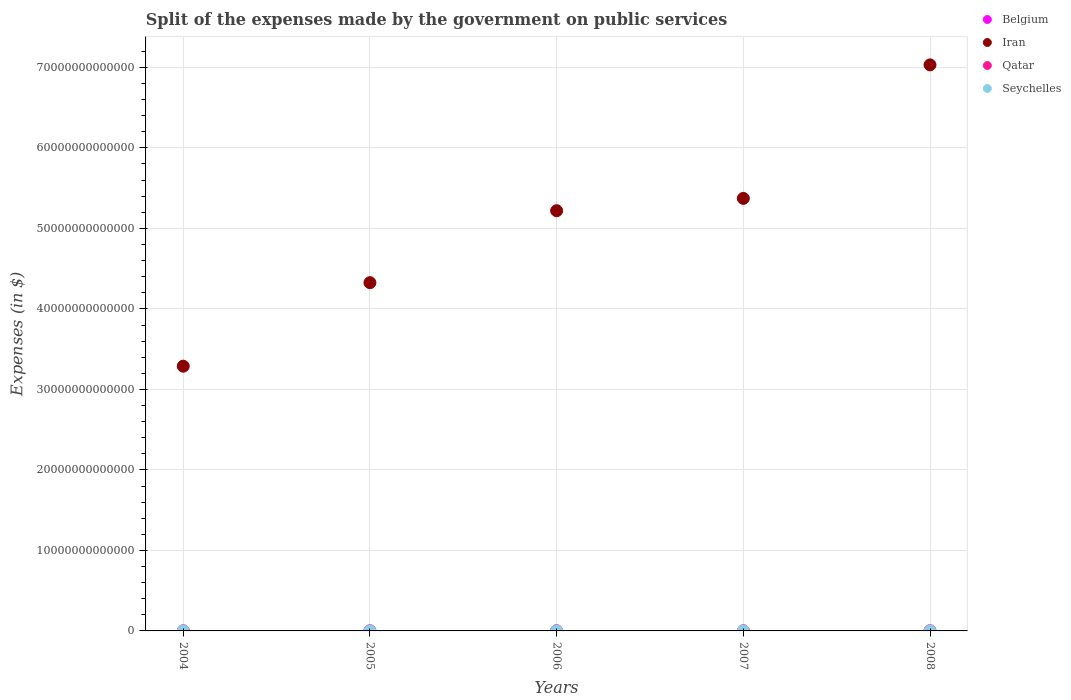What is the expenses made by the government on public services in Iran in 2008?
Offer a very short reply. 7.03e+13. Across all years, what is the maximum expenses made by the government on public services in Seychelles?
Your response must be concise. 6.48e+08. Across all years, what is the minimum expenses made by the government on public services in Iran?
Your response must be concise. 3.29e+13. In which year was the expenses made by the government on public services in Seychelles maximum?
Your answer should be compact. 2008. What is the total expenses made by the government on public services in Belgium in the graph?
Make the answer very short. 1.69e+1. What is the difference between the expenses made by the government on public services in Qatar in 2005 and that in 2006?
Your answer should be compact. -5.73e+09. What is the difference between the expenses made by the government on public services in Qatar in 2005 and the expenses made by the government on public services in Seychelles in 2008?
Your answer should be very brief. 1.16e+1. What is the average expenses made by the government on public services in Seychelles per year?
Offer a very short reply. 5.17e+08. In the year 2008, what is the difference between the expenses made by the government on public services in Seychelles and expenses made by the government on public services in Belgium?
Give a very brief answer. -3.30e+09. What is the ratio of the expenses made by the government on public services in Belgium in 2005 to that in 2007?
Provide a succinct answer. 0.93. Is the expenses made by the government on public services in Seychelles in 2006 less than that in 2008?
Ensure brevity in your answer.  Yes. Is the difference between the expenses made by the government on public services in Seychelles in 2004 and 2008 greater than the difference between the expenses made by the government on public services in Belgium in 2004 and 2008?
Keep it short and to the point. Yes. What is the difference between the highest and the second highest expenses made by the government on public services in Belgium?
Your response must be concise. 5.12e+08. What is the difference between the highest and the lowest expenses made by the government on public services in Seychelles?
Provide a short and direct response. 3.10e+08. Is the sum of the expenses made by the government on public services in Iran in 2005 and 2008 greater than the maximum expenses made by the government on public services in Qatar across all years?
Make the answer very short. Yes. Is it the case that in every year, the sum of the expenses made by the government on public services in Belgium and expenses made by the government on public services in Iran  is greater than the sum of expenses made by the government on public services in Qatar and expenses made by the government on public services in Seychelles?
Your answer should be compact. Yes. Does the expenses made by the government on public services in Iran monotonically increase over the years?
Provide a short and direct response. Yes. What is the difference between two consecutive major ticks on the Y-axis?
Your answer should be compact. 1.00e+13. Does the graph contain grids?
Ensure brevity in your answer.  Yes. How many legend labels are there?
Offer a very short reply. 4. What is the title of the graph?
Offer a very short reply. Split of the expenses made by the government on public services. Does "Central African Republic" appear as one of the legend labels in the graph?
Make the answer very short. No. What is the label or title of the Y-axis?
Your response must be concise. Expenses (in $). What is the Expenses (in $) in Belgium in 2004?
Your response must be concise. 3.14e+09. What is the Expenses (in $) in Iran in 2004?
Your answer should be very brief. 3.29e+13. What is the Expenses (in $) of Qatar in 2004?
Ensure brevity in your answer.  8.25e+09. What is the Expenses (in $) of Seychelles in 2004?
Your response must be concise. 3.38e+08. What is the Expenses (in $) of Belgium in 2005?
Ensure brevity in your answer.  3.21e+09. What is the Expenses (in $) of Iran in 2005?
Your answer should be compact. 4.33e+13. What is the Expenses (in $) in Qatar in 2005?
Give a very brief answer. 1.22e+1. What is the Expenses (in $) in Seychelles in 2005?
Ensure brevity in your answer.  4.63e+08. What is the Expenses (in $) in Belgium in 2006?
Offer a terse response. 3.16e+09. What is the Expenses (in $) of Iran in 2006?
Your response must be concise. 5.22e+13. What is the Expenses (in $) of Qatar in 2006?
Provide a short and direct response. 1.80e+1. What is the Expenses (in $) of Seychelles in 2006?
Provide a short and direct response. 5.24e+08. What is the Expenses (in $) of Belgium in 2007?
Make the answer very short. 3.44e+09. What is the Expenses (in $) of Iran in 2007?
Ensure brevity in your answer.  5.37e+13. What is the Expenses (in $) in Qatar in 2007?
Provide a short and direct response. 1.13e+1. What is the Expenses (in $) of Seychelles in 2007?
Provide a short and direct response. 6.12e+08. What is the Expenses (in $) of Belgium in 2008?
Your answer should be compact. 3.95e+09. What is the Expenses (in $) in Iran in 2008?
Make the answer very short. 7.03e+13. What is the Expenses (in $) in Qatar in 2008?
Your answer should be very brief. 1.74e+1. What is the Expenses (in $) of Seychelles in 2008?
Your answer should be very brief. 6.48e+08. Across all years, what is the maximum Expenses (in $) in Belgium?
Provide a short and direct response. 3.95e+09. Across all years, what is the maximum Expenses (in $) in Iran?
Your answer should be very brief. 7.03e+13. Across all years, what is the maximum Expenses (in $) in Qatar?
Your answer should be very brief. 1.80e+1. Across all years, what is the maximum Expenses (in $) of Seychelles?
Your answer should be compact. 6.48e+08. Across all years, what is the minimum Expenses (in $) of Belgium?
Keep it short and to the point. 3.14e+09. Across all years, what is the minimum Expenses (in $) of Iran?
Your answer should be compact. 3.29e+13. Across all years, what is the minimum Expenses (in $) in Qatar?
Make the answer very short. 8.25e+09. Across all years, what is the minimum Expenses (in $) in Seychelles?
Offer a terse response. 3.38e+08. What is the total Expenses (in $) in Belgium in the graph?
Make the answer very short. 1.69e+1. What is the total Expenses (in $) in Iran in the graph?
Your answer should be compact. 2.52e+14. What is the total Expenses (in $) in Qatar in the graph?
Offer a terse response. 6.72e+1. What is the total Expenses (in $) of Seychelles in the graph?
Your response must be concise. 2.59e+09. What is the difference between the Expenses (in $) of Belgium in 2004 and that in 2005?
Your response must be concise. -7.35e+07. What is the difference between the Expenses (in $) of Iran in 2004 and that in 2005?
Ensure brevity in your answer.  -1.04e+13. What is the difference between the Expenses (in $) in Qatar in 2004 and that in 2005?
Provide a succinct answer. -3.97e+09. What is the difference between the Expenses (in $) in Seychelles in 2004 and that in 2005?
Ensure brevity in your answer.  -1.25e+08. What is the difference between the Expenses (in $) in Belgium in 2004 and that in 2006?
Your answer should be compact. -1.81e+07. What is the difference between the Expenses (in $) in Iran in 2004 and that in 2006?
Make the answer very short. -1.93e+13. What is the difference between the Expenses (in $) in Qatar in 2004 and that in 2006?
Your answer should be compact. -9.70e+09. What is the difference between the Expenses (in $) of Seychelles in 2004 and that in 2006?
Offer a terse response. -1.86e+08. What is the difference between the Expenses (in $) in Belgium in 2004 and that in 2007?
Your answer should be compact. -2.98e+08. What is the difference between the Expenses (in $) of Iran in 2004 and that in 2007?
Provide a succinct answer. -2.08e+13. What is the difference between the Expenses (in $) in Qatar in 2004 and that in 2007?
Ensure brevity in your answer.  -3.06e+09. What is the difference between the Expenses (in $) of Seychelles in 2004 and that in 2007?
Your answer should be very brief. -2.74e+08. What is the difference between the Expenses (in $) in Belgium in 2004 and that in 2008?
Ensure brevity in your answer.  -8.09e+08. What is the difference between the Expenses (in $) in Iran in 2004 and that in 2008?
Provide a succinct answer. -3.74e+13. What is the difference between the Expenses (in $) in Qatar in 2004 and that in 2008?
Offer a terse response. -9.20e+09. What is the difference between the Expenses (in $) in Seychelles in 2004 and that in 2008?
Keep it short and to the point. -3.10e+08. What is the difference between the Expenses (in $) in Belgium in 2005 and that in 2006?
Your answer should be compact. 5.54e+07. What is the difference between the Expenses (in $) in Iran in 2005 and that in 2006?
Make the answer very short. -8.94e+12. What is the difference between the Expenses (in $) in Qatar in 2005 and that in 2006?
Ensure brevity in your answer.  -5.73e+09. What is the difference between the Expenses (in $) of Seychelles in 2005 and that in 2006?
Your answer should be compact. -6.15e+07. What is the difference between the Expenses (in $) in Belgium in 2005 and that in 2007?
Keep it short and to the point. -2.24e+08. What is the difference between the Expenses (in $) of Iran in 2005 and that in 2007?
Keep it short and to the point. -1.05e+13. What is the difference between the Expenses (in $) in Qatar in 2005 and that in 2007?
Ensure brevity in your answer.  9.13e+08. What is the difference between the Expenses (in $) in Seychelles in 2005 and that in 2007?
Offer a very short reply. -1.49e+08. What is the difference between the Expenses (in $) of Belgium in 2005 and that in 2008?
Make the answer very short. -7.36e+08. What is the difference between the Expenses (in $) of Iran in 2005 and that in 2008?
Provide a short and direct response. -2.71e+13. What is the difference between the Expenses (in $) of Qatar in 2005 and that in 2008?
Offer a terse response. -5.22e+09. What is the difference between the Expenses (in $) in Seychelles in 2005 and that in 2008?
Keep it short and to the point. -1.85e+08. What is the difference between the Expenses (in $) in Belgium in 2006 and that in 2007?
Provide a succinct answer. -2.80e+08. What is the difference between the Expenses (in $) in Iran in 2006 and that in 2007?
Your answer should be compact. -1.53e+12. What is the difference between the Expenses (in $) in Qatar in 2006 and that in 2007?
Give a very brief answer. 6.64e+09. What is the difference between the Expenses (in $) of Seychelles in 2006 and that in 2007?
Give a very brief answer. -8.75e+07. What is the difference between the Expenses (in $) in Belgium in 2006 and that in 2008?
Offer a very short reply. -7.91e+08. What is the difference between the Expenses (in $) of Iran in 2006 and that in 2008?
Keep it short and to the point. -1.81e+13. What is the difference between the Expenses (in $) of Qatar in 2006 and that in 2008?
Offer a terse response. 5.07e+08. What is the difference between the Expenses (in $) of Seychelles in 2006 and that in 2008?
Ensure brevity in your answer.  -1.24e+08. What is the difference between the Expenses (in $) of Belgium in 2007 and that in 2008?
Your response must be concise. -5.12e+08. What is the difference between the Expenses (in $) in Iran in 2007 and that in 2008?
Your response must be concise. -1.66e+13. What is the difference between the Expenses (in $) in Qatar in 2007 and that in 2008?
Offer a very short reply. -6.14e+09. What is the difference between the Expenses (in $) in Seychelles in 2007 and that in 2008?
Keep it short and to the point. -3.60e+07. What is the difference between the Expenses (in $) of Belgium in 2004 and the Expenses (in $) of Iran in 2005?
Make the answer very short. -4.33e+13. What is the difference between the Expenses (in $) of Belgium in 2004 and the Expenses (in $) of Qatar in 2005?
Make the answer very short. -9.08e+09. What is the difference between the Expenses (in $) in Belgium in 2004 and the Expenses (in $) in Seychelles in 2005?
Offer a very short reply. 2.68e+09. What is the difference between the Expenses (in $) of Iran in 2004 and the Expenses (in $) of Qatar in 2005?
Offer a very short reply. 3.29e+13. What is the difference between the Expenses (in $) in Iran in 2004 and the Expenses (in $) in Seychelles in 2005?
Your answer should be compact. 3.29e+13. What is the difference between the Expenses (in $) in Qatar in 2004 and the Expenses (in $) in Seychelles in 2005?
Provide a short and direct response. 7.79e+09. What is the difference between the Expenses (in $) in Belgium in 2004 and the Expenses (in $) in Iran in 2006?
Offer a terse response. -5.22e+13. What is the difference between the Expenses (in $) of Belgium in 2004 and the Expenses (in $) of Qatar in 2006?
Make the answer very short. -1.48e+1. What is the difference between the Expenses (in $) of Belgium in 2004 and the Expenses (in $) of Seychelles in 2006?
Provide a short and direct response. 2.62e+09. What is the difference between the Expenses (in $) of Iran in 2004 and the Expenses (in $) of Qatar in 2006?
Keep it short and to the point. 3.29e+13. What is the difference between the Expenses (in $) in Iran in 2004 and the Expenses (in $) in Seychelles in 2006?
Provide a short and direct response. 3.29e+13. What is the difference between the Expenses (in $) in Qatar in 2004 and the Expenses (in $) in Seychelles in 2006?
Keep it short and to the point. 7.72e+09. What is the difference between the Expenses (in $) of Belgium in 2004 and the Expenses (in $) of Iran in 2007?
Your response must be concise. -5.37e+13. What is the difference between the Expenses (in $) in Belgium in 2004 and the Expenses (in $) in Qatar in 2007?
Ensure brevity in your answer.  -8.17e+09. What is the difference between the Expenses (in $) of Belgium in 2004 and the Expenses (in $) of Seychelles in 2007?
Provide a short and direct response. 2.53e+09. What is the difference between the Expenses (in $) in Iran in 2004 and the Expenses (in $) in Qatar in 2007?
Your response must be concise. 3.29e+13. What is the difference between the Expenses (in $) of Iran in 2004 and the Expenses (in $) of Seychelles in 2007?
Keep it short and to the point. 3.29e+13. What is the difference between the Expenses (in $) in Qatar in 2004 and the Expenses (in $) in Seychelles in 2007?
Your answer should be very brief. 7.64e+09. What is the difference between the Expenses (in $) of Belgium in 2004 and the Expenses (in $) of Iran in 2008?
Ensure brevity in your answer.  -7.03e+13. What is the difference between the Expenses (in $) of Belgium in 2004 and the Expenses (in $) of Qatar in 2008?
Give a very brief answer. -1.43e+1. What is the difference between the Expenses (in $) in Belgium in 2004 and the Expenses (in $) in Seychelles in 2008?
Give a very brief answer. 2.49e+09. What is the difference between the Expenses (in $) in Iran in 2004 and the Expenses (in $) in Qatar in 2008?
Your answer should be compact. 3.29e+13. What is the difference between the Expenses (in $) in Iran in 2004 and the Expenses (in $) in Seychelles in 2008?
Your answer should be very brief. 3.29e+13. What is the difference between the Expenses (in $) in Qatar in 2004 and the Expenses (in $) in Seychelles in 2008?
Your response must be concise. 7.60e+09. What is the difference between the Expenses (in $) in Belgium in 2005 and the Expenses (in $) in Iran in 2006?
Your answer should be very brief. -5.22e+13. What is the difference between the Expenses (in $) of Belgium in 2005 and the Expenses (in $) of Qatar in 2006?
Provide a short and direct response. -1.47e+1. What is the difference between the Expenses (in $) in Belgium in 2005 and the Expenses (in $) in Seychelles in 2006?
Your answer should be very brief. 2.69e+09. What is the difference between the Expenses (in $) of Iran in 2005 and the Expenses (in $) of Qatar in 2006?
Keep it short and to the point. 4.32e+13. What is the difference between the Expenses (in $) of Iran in 2005 and the Expenses (in $) of Seychelles in 2006?
Provide a short and direct response. 4.33e+13. What is the difference between the Expenses (in $) in Qatar in 2005 and the Expenses (in $) in Seychelles in 2006?
Keep it short and to the point. 1.17e+1. What is the difference between the Expenses (in $) in Belgium in 2005 and the Expenses (in $) in Iran in 2007?
Offer a very short reply. -5.37e+13. What is the difference between the Expenses (in $) in Belgium in 2005 and the Expenses (in $) in Qatar in 2007?
Make the answer very short. -8.10e+09. What is the difference between the Expenses (in $) of Belgium in 2005 and the Expenses (in $) of Seychelles in 2007?
Provide a short and direct response. 2.60e+09. What is the difference between the Expenses (in $) in Iran in 2005 and the Expenses (in $) in Qatar in 2007?
Provide a succinct answer. 4.32e+13. What is the difference between the Expenses (in $) of Iran in 2005 and the Expenses (in $) of Seychelles in 2007?
Provide a succinct answer. 4.33e+13. What is the difference between the Expenses (in $) in Qatar in 2005 and the Expenses (in $) in Seychelles in 2007?
Your response must be concise. 1.16e+1. What is the difference between the Expenses (in $) in Belgium in 2005 and the Expenses (in $) in Iran in 2008?
Your answer should be compact. -7.03e+13. What is the difference between the Expenses (in $) in Belgium in 2005 and the Expenses (in $) in Qatar in 2008?
Provide a succinct answer. -1.42e+1. What is the difference between the Expenses (in $) of Belgium in 2005 and the Expenses (in $) of Seychelles in 2008?
Ensure brevity in your answer.  2.57e+09. What is the difference between the Expenses (in $) of Iran in 2005 and the Expenses (in $) of Qatar in 2008?
Your response must be concise. 4.32e+13. What is the difference between the Expenses (in $) of Iran in 2005 and the Expenses (in $) of Seychelles in 2008?
Provide a short and direct response. 4.33e+13. What is the difference between the Expenses (in $) of Qatar in 2005 and the Expenses (in $) of Seychelles in 2008?
Your answer should be compact. 1.16e+1. What is the difference between the Expenses (in $) of Belgium in 2006 and the Expenses (in $) of Iran in 2007?
Offer a terse response. -5.37e+13. What is the difference between the Expenses (in $) of Belgium in 2006 and the Expenses (in $) of Qatar in 2007?
Your answer should be very brief. -8.15e+09. What is the difference between the Expenses (in $) of Belgium in 2006 and the Expenses (in $) of Seychelles in 2007?
Provide a short and direct response. 2.55e+09. What is the difference between the Expenses (in $) of Iran in 2006 and the Expenses (in $) of Qatar in 2007?
Offer a terse response. 5.22e+13. What is the difference between the Expenses (in $) in Iran in 2006 and the Expenses (in $) in Seychelles in 2007?
Provide a short and direct response. 5.22e+13. What is the difference between the Expenses (in $) of Qatar in 2006 and the Expenses (in $) of Seychelles in 2007?
Offer a very short reply. 1.73e+1. What is the difference between the Expenses (in $) in Belgium in 2006 and the Expenses (in $) in Iran in 2008?
Provide a short and direct response. -7.03e+13. What is the difference between the Expenses (in $) of Belgium in 2006 and the Expenses (in $) of Qatar in 2008?
Ensure brevity in your answer.  -1.43e+1. What is the difference between the Expenses (in $) of Belgium in 2006 and the Expenses (in $) of Seychelles in 2008?
Offer a terse response. 2.51e+09. What is the difference between the Expenses (in $) in Iran in 2006 and the Expenses (in $) in Qatar in 2008?
Give a very brief answer. 5.22e+13. What is the difference between the Expenses (in $) in Iran in 2006 and the Expenses (in $) in Seychelles in 2008?
Give a very brief answer. 5.22e+13. What is the difference between the Expenses (in $) in Qatar in 2006 and the Expenses (in $) in Seychelles in 2008?
Offer a terse response. 1.73e+1. What is the difference between the Expenses (in $) of Belgium in 2007 and the Expenses (in $) of Iran in 2008?
Offer a terse response. -7.03e+13. What is the difference between the Expenses (in $) in Belgium in 2007 and the Expenses (in $) in Qatar in 2008?
Make the answer very short. -1.40e+1. What is the difference between the Expenses (in $) of Belgium in 2007 and the Expenses (in $) of Seychelles in 2008?
Make the answer very short. 2.79e+09. What is the difference between the Expenses (in $) of Iran in 2007 and the Expenses (in $) of Qatar in 2008?
Provide a succinct answer. 5.37e+13. What is the difference between the Expenses (in $) in Iran in 2007 and the Expenses (in $) in Seychelles in 2008?
Make the answer very short. 5.37e+13. What is the difference between the Expenses (in $) of Qatar in 2007 and the Expenses (in $) of Seychelles in 2008?
Offer a very short reply. 1.07e+1. What is the average Expenses (in $) in Belgium per year?
Offer a very short reply. 3.38e+09. What is the average Expenses (in $) in Iran per year?
Your answer should be very brief. 5.05e+13. What is the average Expenses (in $) of Qatar per year?
Offer a very short reply. 1.34e+1. What is the average Expenses (in $) of Seychelles per year?
Your response must be concise. 5.17e+08. In the year 2004, what is the difference between the Expenses (in $) of Belgium and Expenses (in $) of Iran?
Offer a terse response. -3.29e+13. In the year 2004, what is the difference between the Expenses (in $) in Belgium and Expenses (in $) in Qatar?
Your answer should be very brief. -5.11e+09. In the year 2004, what is the difference between the Expenses (in $) of Belgium and Expenses (in $) of Seychelles?
Your response must be concise. 2.80e+09. In the year 2004, what is the difference between the Expenses (in $) in Iran and Expenses (in $) in Qatar?
Provide a short and direct response. 3.29e+13. In the year 2004, what is the difference between the Expenses (in $) in Iran and Expenses (in $) in Seychelles?
Make the answer very short. 3.29e+13. In the year 2004, what is the difference between the Expenses (in $) in Qatar and Expenses (in $) in Seychelles?
Your response must be concise. 7.91e+09. In the year 2005, what is the difference between the Expenses (in $) of Belgium and Expenses (in $) of Iran?
Ensure brevity in your answer.  -4.33e+13. In the year 2005, what is the difference between the Expenses (in $) in Belgium and Expenses (in $) in Qatar?
Provide a short and direct response. -9.01e+09. In the year 2005, what is the difference between the Expenses (in $) of Belgium and Expenses (in $) of Seychelles?
Your response must be concise. 2.75e+09. In the year 2005, what is the difference between the Expenses (in $) of Iran and Expenses (in $) of Qatar?
Provide a succinct answer. 4.32e+13. In the year 2005, what is the difference between the Expenses (in $) in Iran and Expenses (in $) in Seychelles?
Your answer should be compact. 4.33e+13. In the year 2005, what is the difference between the Expenses (in $) of Qatar and Expenses (in $) of Seychelles?
Your answer should be compact. 1.18e+1. In the year 2006, what is the difference between the Expenses (in $) of Belgium and Expenses (in $) of Iran?
Ensure brevity in your answer.  -5.22e+13. In the year 2006, what is the difference between the Expenses (in $) of Belgium and Expenses (in $) of Qatar?
Provide a succinct answer. -1.48e+1. In the year 2006, what is the difference between the Expenses (in $) in Belgium and Expenses (in $) in Seychelles?
Your response must be concise. 2.63e+09. In the year 2006, what is the difference between the Expenses (in $) of Iran and Expenses (in $) of Qatar?
Your answer should be very brief. 5.22e+13. In the year 2006, what is the difference between the Expenses (in $) in Iran and Expenses (in $) in Seychelles?
Your response must be concise. 5.22e+13. In the year 2006, what is the difference between the Expenses (in $) of Qatar and Expenses (in $) of Seychelles?
Make the answer very short. 1.74e+1. In the year 2007, what is the difference between the Expenses (in $) of Belgium and Expenses (in $) of Iran?
Your answer should be very brief. -5.37e+13. In the year 2007, what is the difference between the Expenses (in $) of Belgium and Expenses (in $) of Qatar?
Your response must be concise. -7.87e+09. In the year 2007, what is the difference between the Expenses (in $) in Belgium and Expenses (in $) in Seychelles?
Your answer should be compact. 2.83e+09. In the year 2007, what is the difference between the Expenses (in $) of Iran and Expenses (in $) of Qatar?
Your answer should be very brief. 5.37e+13. In the year 2007, what is the difference between the Expenses (in $) in Iran and Expenses (in $) in Seychelles?
Offer a terse response. 5.37e+13. In the year 2007, what is the difference between the Expenses (in $) in Qatar and Expenses (in $) in Seychelles?
Offer a terse response. 1.07e+1. In the year 2008, what is the difference between the Expenses (in $) in Belgium and Expenses (in $) in Iran?
Ensure brevity in your answer.  -7.03e+13. In the year 2008, what is the difference between the Expenses (in $) of Belgium and Expenses (in $) of Qatar?
Keep it short and to the point. -1.35e+1. In the year 2008, what is the difference between the Expenses (in $) of Belgium and Expenses (in $) of Seychelles?
Keep it short and to the point. 3.30e+09. In the year 2008, what is the difference between the Expenses (in $) in Iran and Expenses (in $) in Qatar?
Make the answer very short. 7.03e+13. In the year 2008, what is the difference between the Expenses (in $) in Iran and Expenses (in $) in Seychelles?
Offer a very short reply. 7.03e+13. In the year 2008, what is the difference between the Expenses (in $) of Qatar and Expenses (in $) of Seychelles?
Your response must be concise. 1.68e+1. What is the ratio of the Expenses (in $) in Belgium in 2004 to that in 2005?
Your response must be concise. 0.98. What is the ratio of the Expenses (in $) of Iran in 2004 to that in 2005?
Keep it short and to the point. 0.76. What is the ratio of the Expenses (in $) of Qatar in 2004 to that in 2005?
Make the answer very short. 0.67. What is the ratio of the Expenses (in $) in Seychelles in 2004 to that in 2005?
Offer a very short reply. 0.73. What is the ratio of the Expenses (in $) in Iran in 2004 to that in 2006?
Ensure brevity in your answer.  0.63. What is the ratio of the Expenses (in $) of Qatar in 2004 to that in 2006?
Your answer should be very brief. 0.46. What is the ratio of the Expenses (in $) of Seychelles in 2004 to that in 2006?
Provide a succinct answer. 0.65. What is the ratio of the Expenses (in $) of Belgium in 2004 to that in 2007?
Keep it short and to the point. 0.91. What is the ratio of the Expenses (in $) of Iran in 2004 to that in 2007?
Provide a succinct answer. 0.61. What is the ratio of the Expenses (in $) of Qatar in 2004 to that in 2007?
Keep it short and to the point. 0.73. What is the ratio of the Expenses (in $) of Seychelles in 2004 to that in 2007?
Offer a terse response. 0.55. What is the ratio of the Expenses (in $) in Belgium in 2004 to that in 2008?
Your answer should be compact. 0.8. What is the ratio of the Expenses (in $) of Iran in 2004 to that in 2008?
Offer a very short reply. 0.47. What is the ratio of the Expenses (in $) of Qatar in 2004 to that in 2008?
Offer a very short reply. 0.47. What is the ratio of the Expenses (in $) of Seychelles in 2004 to that in 2008?
Your answer should be compact. 0.52. What is the ratio of the Expenses (in $) of Belgium in 2005 to that in 2006?
Offer a very short reply. 1.02. What is the ratio of the Expenses (in $) in Iran in 2005 to that in 2006?
Provide a short and direct response. 0.83. What is the ratio of the Expenses (in $) of Qatar in 2005 to that in 2006?
Make the answer very short. 0.68. What is the ratio of the Expenses (in $) of Seychelles in 2005 to that in 2006?
Your answer should be compact. 0.88. What is the ratio of the Expenses (in $) of Belgium in 2005 to that in 2007?
Provide a short and direct response. 0.93. What is the ratio of the Expenses (in $) of Iran in 2005 to that in 2007?
Keep it short and to the point. 0.81. What is the ratio of the Expenses (in $) of Qatar in 2005 to that in 2007?
Keep it short and to the point. 1.08. What is the ratio of the Expenses (in $) in Seychelles in 2005 to that in 2007?
Offer a terse response. 0.76. What is the ratio of the Expenses (in $) of Belgium in 2005 to that in 2008?
Provide a short and direct response. 0.81. What is the ratio of the Expenses (in $) in Iran in 2005 to that in 2008?
Provide a succinct answer. 0.62. What is the ratio of the Expenses (in $) of Qatar in 2005 to that in 2008?
Offer a very short reply. 0.7. What is the ratio of the Expenses (in $) in Seychelles in 2005 to that in 2008?
Make the answer very short. 0.71. What is the ratio of the Expenses (in $) of Belgium in 2006 to that in 2007?
Provide a short and direct response. 0.92. What is the ratio of the Expenses (in $) in Iran in 2006 to that in 2007?
Ensure brevity in your answer.  0.97. What is the ratio of the Expenses (in $) of Qatar in 2006 to that in 2007?
Offer a terse response. 1.59. What is the ratio of the Expenses (in $) in Seychelles in 2006 to that in 2007?
Offer a terse response. 0.86. What is the ratio of the Expenses (in $) of Belgium in 2006 to that in 2008?
Your answer should be very brief. 0.8. What is the ratio of the Expenses (in $) of Iran in 2006 to that in 2008?
Give a very brief answer. 0.74. What is the ratio of the Expenses (in $) in Qatar in 2006 to that in 2008?
Give a very brief answer. 1.03. What is the ratio of the Expenses (in $) of Seychelles in 2006 to that in 2008?
Give a very brief answer. 0.81. What is the ratio of the Expenses (in $) of Belgium in 2007 to that in 2008?
Your response must be concise. 0.87. What is the ratio of the Expenses (in $) of Iran in 2007 to that in 2008?
Give a very brief answer. 0.76. What is the ratio of the Expenses (in $) of Qatar in 2007 to that in 2008?
Provide a short and direct response. 0.65. What is the ratio of the Expenses (in $) of Seychelles in 2007 to that in 2008?
Provide a succinct answer. 0.94. What is the difference between the highest and the second highest Expenses (in $) of Belgium?
Ensure brevity in your answer.  5.12e+08. What is the difference between the highest and the second highest Expenses (in $) in Iran?
Offer a very short reply. 1.66e+13. What is the difference between the highest and the second highest Expenses (in $) in Qatar?
Ensure brevity in your answer.  5.07e+08. What is the difference between the highest and the second highest Expenses (in $) in Seychelles?
Keep it short and to the point. 3.60e+07. What is the difference between the highest and the lowest Expenses (in $) of Belgium?
Make the answer very short. 8.09e+08. What is the difference between the highest and the lowest Expenses (in $) of Iran?
Offer a terse response. 3.74e+13. What is the difference between the highest and the lowest Expenses (in $) in Qatar?
Keep it short and to the point. 9.70e+09. What is the difference between the highest and the lowest Expenses (in $) in Seychelles?
Your response must be concise. 3.10e+08. 